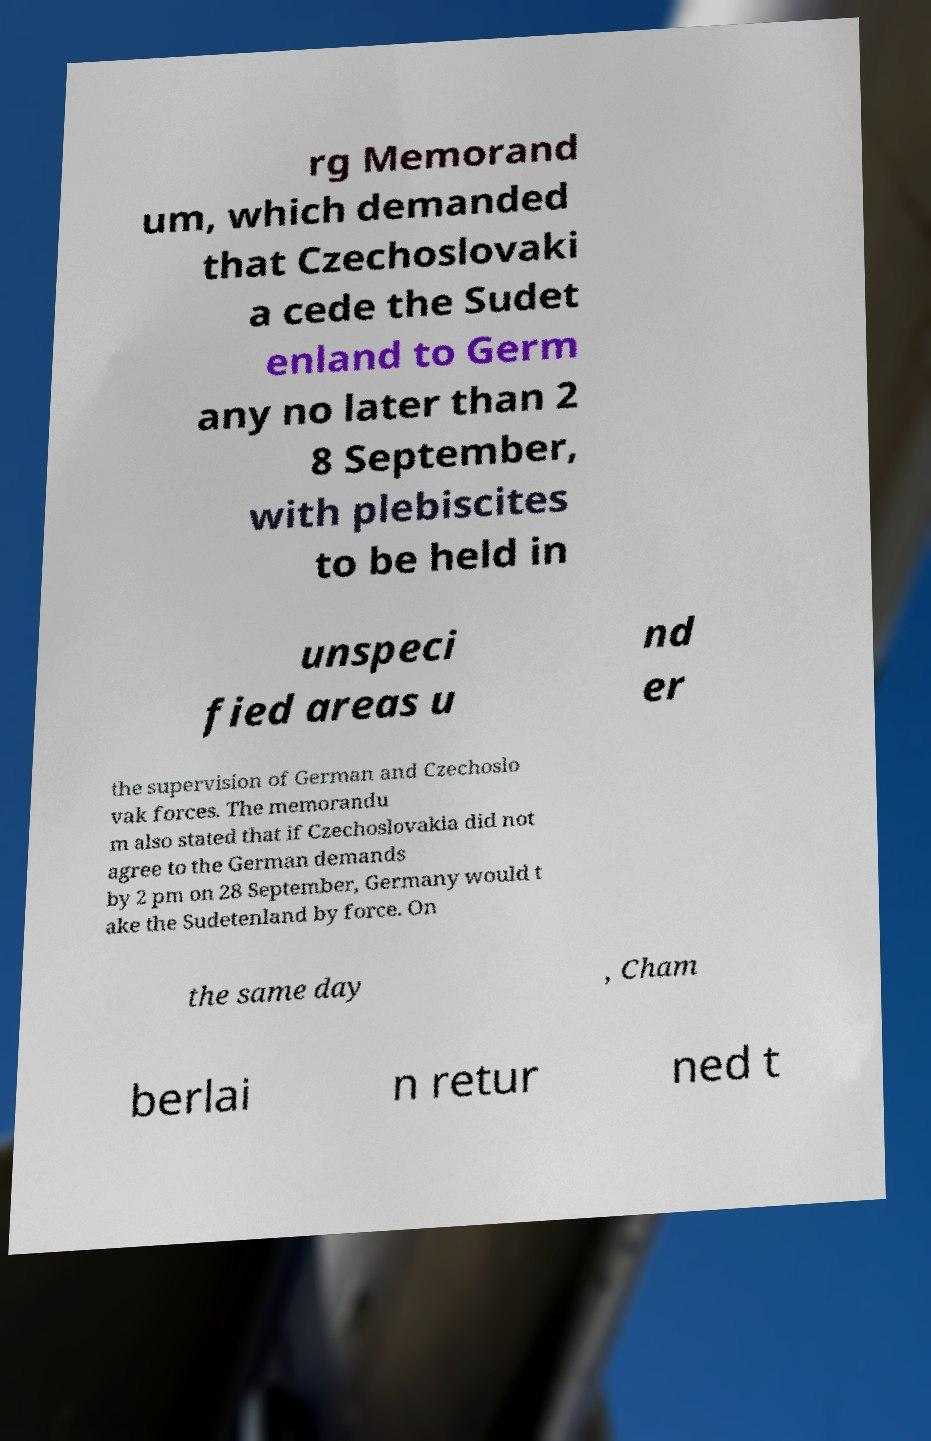Please read and relay the text visible in this image. What does it say? rg Memorand um, which demanded that Czechoslovaki a cede the Sudet enland to Germ any no later than 2 8 September, with plebiscites to be held in unspeci fied areas u nd er the supervision of German and Czechoslo vak forces. The memorandu m also stated that if Czechoslovakia did not agree to the German demands by 2 pm on 28 September, Germany would t ake the Sudetenland by force. On the same day , Cham berlai n retur ned t 